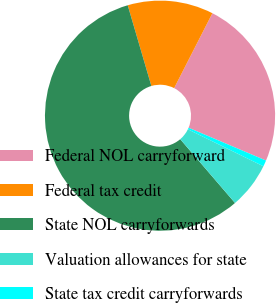Convert chart to OTSL. <chart><loc_0><loc_0><loc_500><loc_500><pie_chart><fcel>Federal NOL carryforward<fcel>Federal tax credit<fcel>State NOL carryforwards<fcel>Valuation allowances for state<fcel>State tax credit carryforwards<nl><fcel>23.86%<fcel>12.05%<fcel>56.76%<fcel>6.46%<fcel>0.87%<nl></chart> 